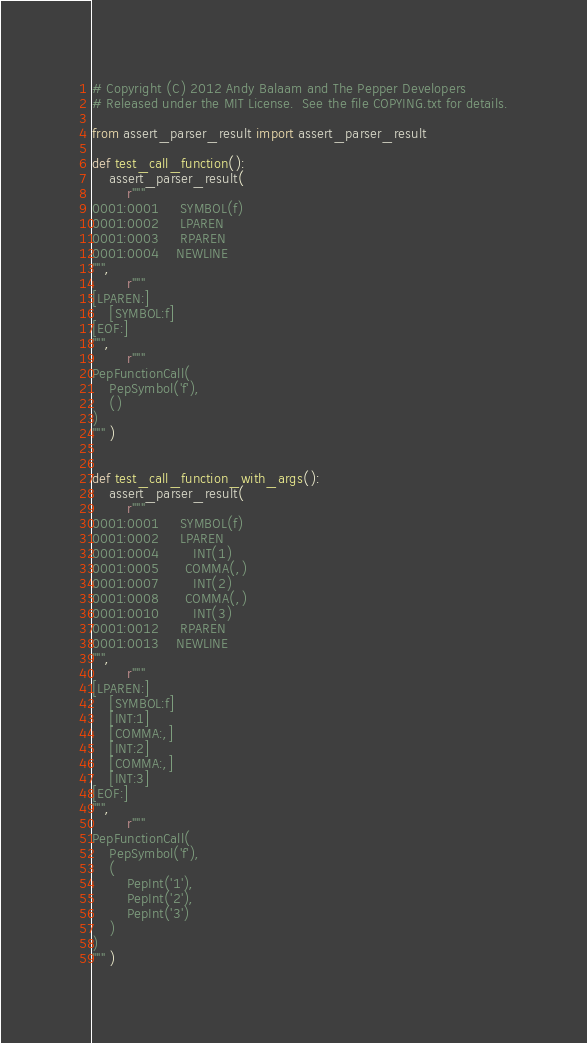<code> <loc_0><loc_0><loc_500><loc_500><_Python_># Copyright (C) 2012 Andy Balaam and The Pepper Developers
# Released under the MIT License.  See the file COPYING.txt for details.

from assert_parser_result import assert_parser_result

def test_call_function():
    assert_parser_result(
        r"""
0001:0001     SYMBOL(f)
0001:0002     LPAREN
0001:0003     RPAREN
0001:0004    NEWLINE
""",
        r"""
[LPAREN:]
    [SYMBOL:f]
[EOF:]
""",
        r"""
PepFunctionCall(
    PepSymbol('f'),
    ()
)
""" )


def test_call_function_with_args():
    assert_parser_result(
        r"""
0001:0001     SYMBOL(f)
0001:0002     LPAREN
0001:0004        INT(1)
0001:0005      COMMA(,)
0001:0007        INT(2)
0001:0008      COMMA(,)
0001:0010        INT(3)
0001:0012     RPAREN
0001:0013    NEWLINE
""",
        r"""
[LPAREN:]
    [SYMBOL:f]
    [INT:1]
    [COMMA:,]
    [INT:2]
    [COMMA:,]
    [INT:3]
[EOF:]
""",
        r"""
PepFunctionCall(
    PepSymbol('f'),
    (
        PepInt('1'), 
        PepInt('2'), 
        PepInt('3')
    )
)
""" )

</code> 